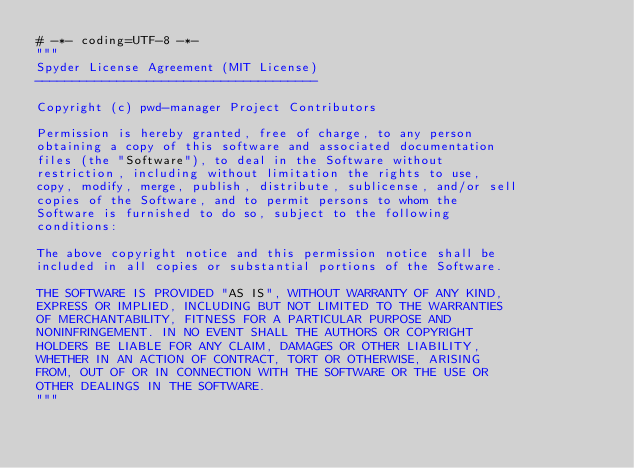Convert code to text. <code><loc_0><loc_0><loc_500><loc_500><_Python_># -*- coding=UTF-8 -*-
"""
Spyder License Agreement (MIT License)
--------------------------------------

Copyright (c) pwd-manager Project Contributors

Permission is hereby granted, free of charge, to any person
obtaining a copy of this software and associated documentation
files (the "Software"), to deal in the Software without
restriction, including without limitation the rights to use,
copy, modify, merge, publish, distribute, sublicense, and/or sell
copies of the Software, and to permit persons to whom the
Software is furnished to do so, subject to the following
conditions:

The above copyright notice and this permission notice shall be
included in all copies or substantial portions of the Software.

THE SOFTWARE IS PROVIDED "AS IS", WITHOUT WARRANTY OF ANY KIND,
EXPRESS OR IMPLIED, INCLUDING BUT NOT LIMITED TO THE WARRANTIES
OF MERCHANTABILITY, FITNESS FOR A PARTICULAR PURPOSE AND
NONINFRINGEMENT. IN NO EVENT SHALL THE AUTHORS OR COPYRIGHT
HOLDERS BE LIABLE FOR ANY CLAIM, DAMAGES OR OTHER LIABILITY,
WHETHER IN AN ACTION OF CONTRACT, TORT OR OTHERWISE, ARISING
FROM, OUT OF OR IN CONNECTION WITH THE SOFTWARE OR THE USE OR
OTHER DEALINGS IN THE SOFTWARE.
"""</code> 